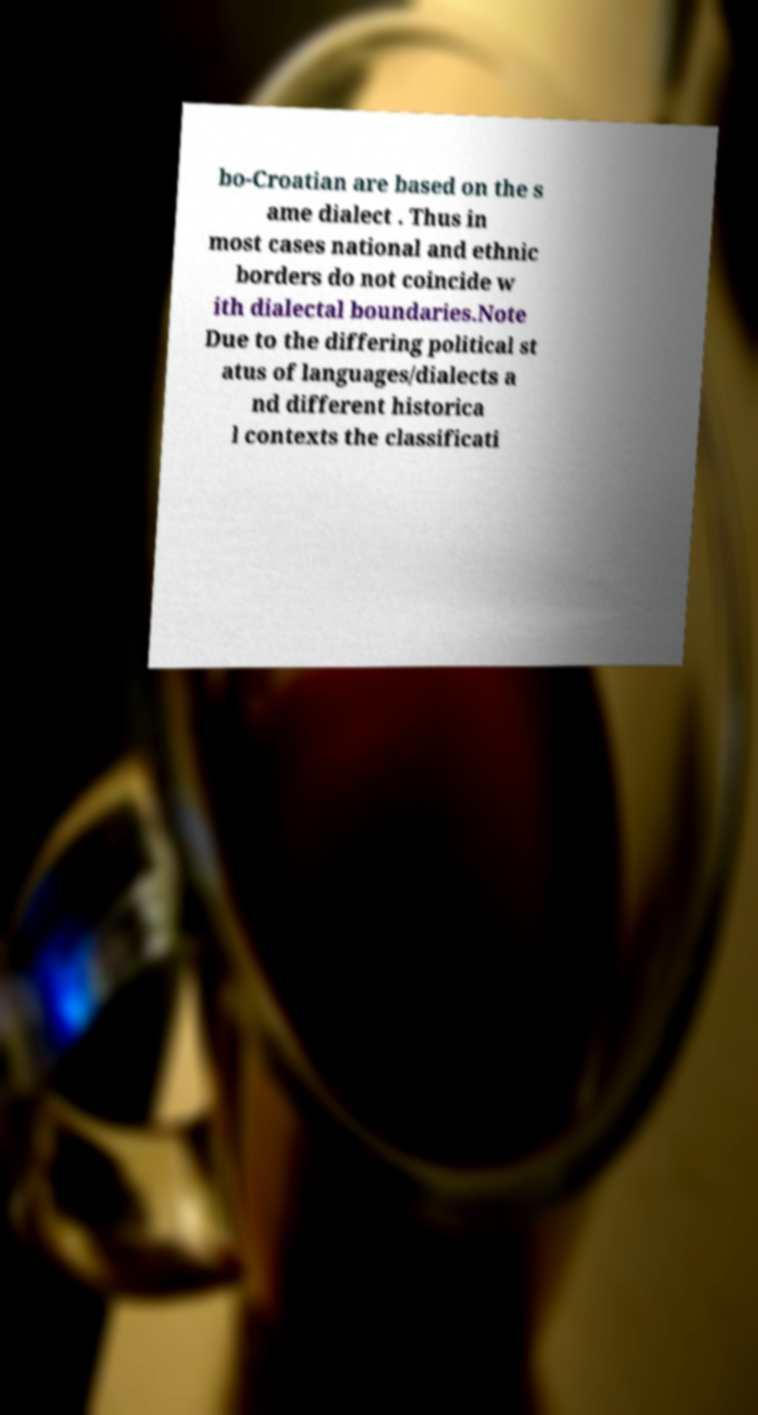Please read and relay the text visible in this image. What does it say? bo-Croatian are based on the s ame dialect . Thus in most cases national and ethnic borders do not coincide w ith dialectal boundaries.Note Due to the differing political st atus of languages/dialects a nd different historica l contexts the classificati 